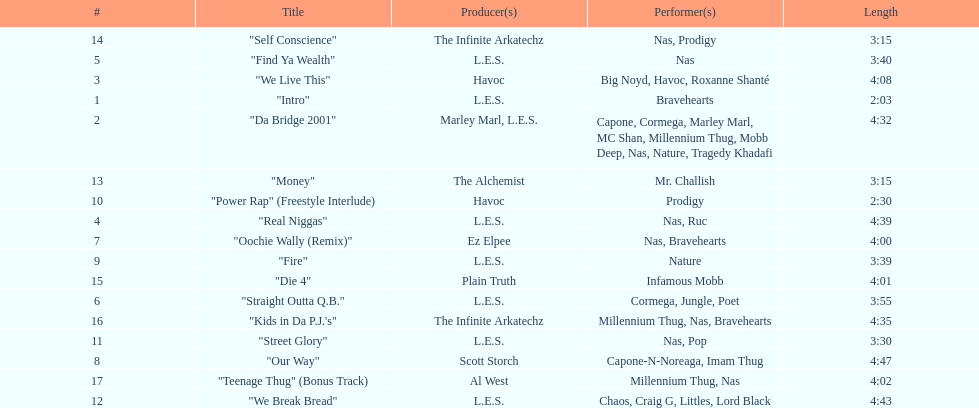After street glory, what song is listed? "We Break Bread". 